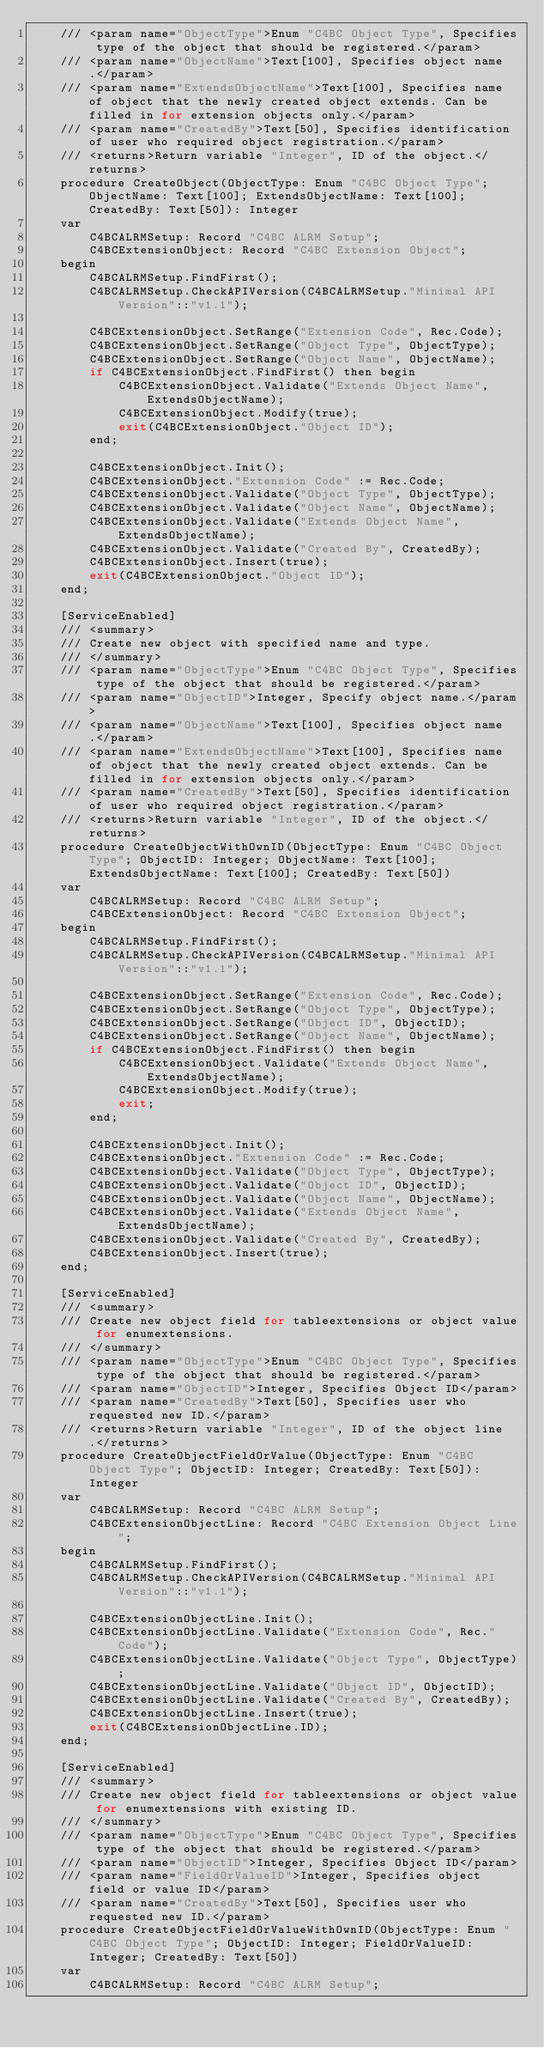<code> <loc_0><loc_0><loc_500><loc_500><_Perl_>    /// <param name="ObjectType">Enum "C4BC Object Type", Specifies type of the object that should be registered.</param>
    /// <param name="ObjectName">Text[100], Specifies object name.</param>
    /// <param name="ExtendsObjectName">Text[100], Specifies name of object that the newly created object extends. Can be filled in for extension objects only.</param>
    /// <param name="CreatedBy">Text[50], Specifies identification of user who required object registration.</param>
    /// <returns>Return variable "Integer", ID of the object.</returns>
    procedure CreateObject(ObjectType: Enum "C4BC Object Type"; ObjectName: Text[100]; ExtendsObjectName: Text[100]; CreatedBy: Text[50]): Integer
    var
        C4BCALRMSetup: Record "C4BC ALRM Setup";
        C4BCExtensionObject: Record "C4BC Extension Object";
    begin
        C4BCALRMSetup.FindFirst();
        C4BCALRMSetup.CheckAPIVersion(C4BCALRMSetup."Minimal API Version"::"v1.1");

        C4BCExtensionObject.SetRange("Extension Code", Rec.Code);
        C4BCExtensionObject.SetRange("Object Type", ObjectType);
        C4BCExtensionObject.SetRange("Object Name", ObjectName);
        if C4BCExtensionObject.FindFirst() then begin
            C4BCExtensionObject.Validate("Extends Object Name", ExtendsObjectName);
            C4BCExtensionObject.Modify(true);
            exit(C4BCExtensionObject."Object ID");
        end;

        C4BCExtensionObject.Init();
        C4BCExtensionObject."Extension Code" := Rec.Code;
        C4BCExtensionObject.Validate("Object Type", ObjectType);
        C4BCExtensionObject.Validate("Object Name", ObjectName);
        C4BCExtensionObject.Validate("Extends Object Name", ExtendsObjectName);
        C4BCExtensionObject.Validate("Created By", CreatedBy);
        C4BCExtensionObject.Insert(true);
        exit(C4BCExtensionObject."Object ID");
    end;

    [ServiceEnabled]
    /// <summary> 
    /// Create new object with specified name and type.
    /// </summary>
    /// <param name="ObjectType">Enum "C4BC Object Type", Specifies type of the object that should be registered.</param>
    /// <param name="ObjectID">Integer, Specify object name.</param>
    /// <param name="ObjectName">Text[100], Specifies object name.</param>
    /// <param name="ExtendsObjectName">Text[100], Specifies name of object that the newly created object extends. Can be filled in for extension objects only.</param>
    /// <param name="CreatedBy">Text[50], Specifies identification of user who required object registration.</param>
    /// <returns>Return variable "Integer", ID of the object.</returns>
    procedure CreateObjectWithOwnID(ObjectType: Enum "C4BC Object Type"; ObjectID: Integer; ObjectName: Text[100]; ExtendsObjectName: Text[100]; CreatedBy: Text[50])
    var
        C4BCALRMSetup: Record "C4BC ALRM Setup";
        C4BCExtensionObject: Record "C4BC Extension Object";
    begin
        C4BCALRMSetup.FindFirst();
        C4BCALRMSetup.CheckAPIVersion(C4BCALRMSetup."Minimal API Version"::"v1.1");

        C4BCExtensionObject.SetRange("Extension Code", Rec.Code);
        C4BCExtensionObject.SetRange("Object Type", ObjectType);
        C4BCExtensionObject.SetRange("Object ID", ObjectID);
        C4BCExtensionObject.SetRange("Object Name", ObjectName);
        if C4BCExtensionObject.FindFirst() then begin
            C4BCExtensionObject.Validate("Extends Object Name", ExtendsObjectName);
            C4BCExtensionObject.Modify(true);
            exit;
        end;

        C4BCExtensionObject.Init();
        C4BCExtensionObject."Extension Code" := Rec.Code;
        C4BCExtensionObject.Validate("Object Type", ObjectType);
        C4BCExtensionObject.Validate("Object ID", ObjectID);
        C4BCExtensionObject.Validate("Object Name", ObjectName);
        C4BCExtensionObject.Validate("Extends Object Name", ExtendsObjectName);
        C4BCExtensionObject.Validate("Created By", CreatedBy);
        C4BCExtensionObject.Insert(true);
    end;

    [ServiceEnabled]
    /// <summary>
    /// Create new object field for tableextensions or object value for enumextensions.
    /// </summary>
    /// <param name="ObjectType">Enum "C4BC Object Type", Specifies type of the object that should be registered.</param>
    /// <param name="ObjectID">Integer, Specifies Object ID</param>
    /// <param name="CreatedBy">Text[50], Specifies user who requested new ID.</param>
    /// <returns>Return variable "Integer", ID of the object line.</returns>
    procedure CreateObjectFieldOrValue(ObjectType: Enum "C4BC Object Type"; ObjectID: Integer; CreatedBy: Text[50]): Integer
    var
        C4BCALRMSetup: Record "C4BC ALRM Setup";
        C4BCExtensionObjectLine: Record "C4BC Extension Object Line";
    begin
        C4BCALRMSetup.FindFirst();
        C4BCALRMSetup.CheckAPIVersion(C4BCALRMSetup."Minimal API Version"::"v1.1");

        C4BCExtensionObjectLine.Init();
        C4BCExtensionObjectLine.Validate("Extension Code", Rec."Code");
        C4BCExtensionObjectLine.Validate("Object Type", ObjectType);
        C4BCExtensionObjectLine.Validate("Object ID", ObjectID);
        C4BCExtensionObjectLine.Validate("Created By", CreatedBy);
        C4BCExtensionObjectLine.Insert(true);
        exit(C4BCExtensionObjectLine.ID);
    end;

    [ServiceEnabled]
    /// <summary>
    /// Create new object field for tableextensions or object value for enumextensions with existing ID.
    /// </summary>
    /// <param name="ObjectType">Enum "C4BC Object Type", Specifies type of the object that should be registered.</param>
    /// <param name="ObjectID">Integer, Specifies Object ID</param>
    /// <param name="FieldOrValueID">Integer, Specifies object field or value ID</param>
    /// <param name="CreatedBy">Text[50], Specifies user who requested new ID.</param>
    procedure CreateObjectFieldOrValueWithOwnID(ObjectType: Enum "C4BC Object Type"; ObjectID: Integer; FieldOrValueID: Integer; CreatedBy: Text[50])
    var
        C4BCALRMSetup: Record "C4BC ALRM Setup";</code> 